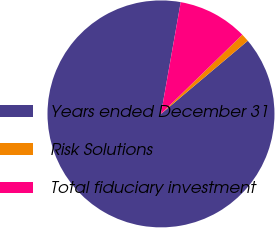Convert chart. <chart><loc_0><loc_0><loc_500><loc_500><pie_chart><fcel>Years ended December 31<fcel>Risk Solutions<fcel>Total fiduciary investment<nl><fcel>88.93%<fcel>1.15%<fcel>9.93%<nl></chart> 